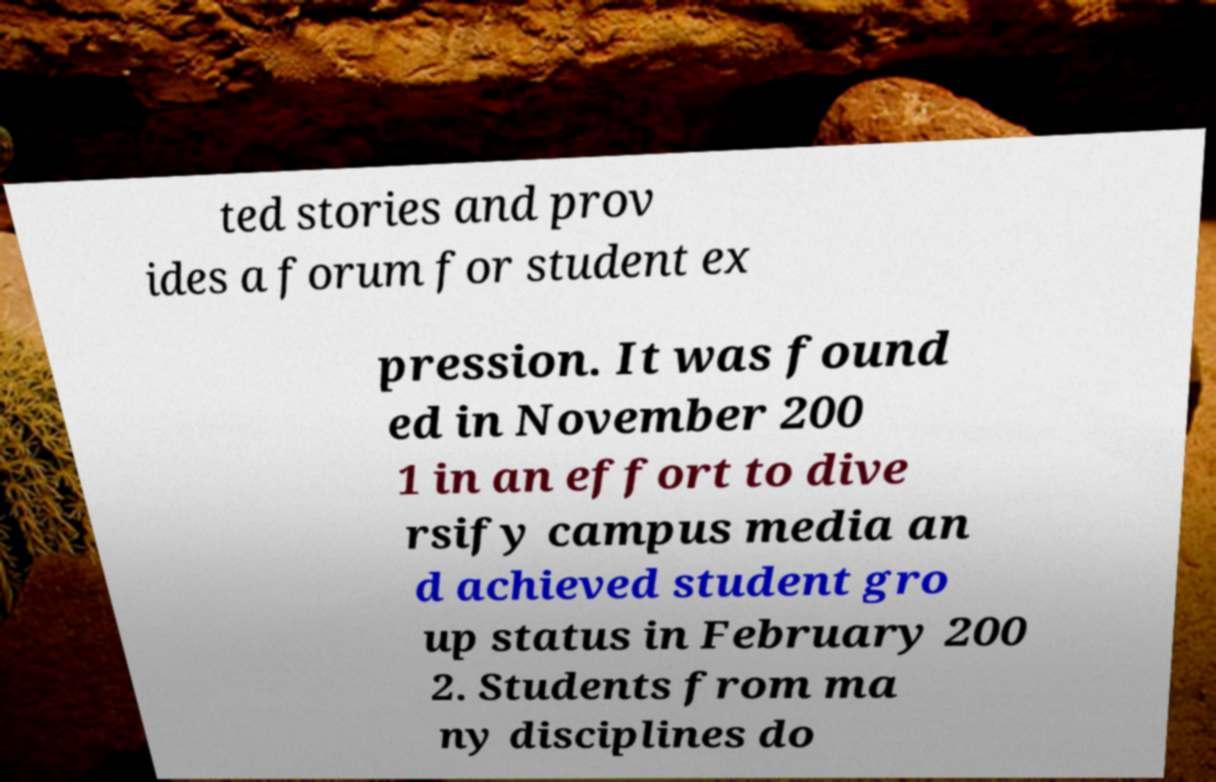Please identify and transcribe the text found in this image. ted stories and prov ides a forum for student ex pression. It was found ed in November 200 1 in an effort to dive rsify campus media an d achieved student gro up status in February 200 2. Students from ma ny disciplines do 